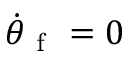Convert formula to latex. <formula><loc_0><loc_0><loc_500><loc_500>\dot { \theta } _ { f } = 0</formula> 